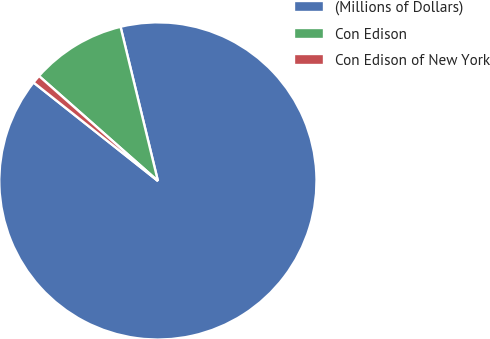Convert chart. <chart><loc_0><loc_0><loc_500><loc_500><pie_chart><fcel>(Millions of Dollars)<fcel>Con Edison<fcel>Con Edison of New York<nl><fcel>89.45%<fcel>9.71%<fcel>0.85%<nl></chart> 